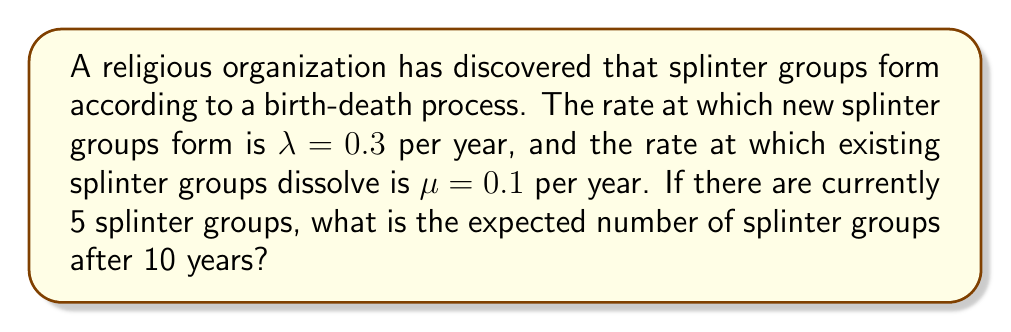What is the answer to this math problem? To solve this problem, we'll use the birth-death process model:

1. The mean number of splinter groups at time t, denoted as $E[N(t)]$, is given by:

   $$E[N(t)] = \frac{\lambda}{\lambda - \mu} + \left(N_0 - \frac{\lambda}{\lambda - \mu}\right)e^{-(\lambda - \mu)t}$$

   where $N_0$ is the initial number of splinter groups.

2. Let's substitute the given values:
   $\lambda = 0.3$, $\mu = 0.1$, $N_0 = 5$, and $t = 10$

3. First, calculate $\frac{\lambda}{\lambda - \mu}$:
   $$\frac{\lambda}{\lambda - \mu} = \frac{0.3}{0.3 - 0.1} = \frac{0.3}{0.2} = 1.5$$

4. Now, let's substitute all values into the equation:

   $$E[N(10)] = 1.5 + \left(5 - 1.5\right)e^{-(0.3 - 0.1)(10)}$$

5. Simplify:
   $$E[N(10)] = 1.5 + 3.5e^{-0.2(10)}$$
   $$E[N(10)] = 1.5 + 3.5e^{-2}$$

6. Calculate $e^{-2} \approx 0.1353$

7. Final calculation:
   $$E[N(10)] = 1.5 + 3.5(0.1353) \approx 1.9736$$
Answer: 1.97 splinter groups 